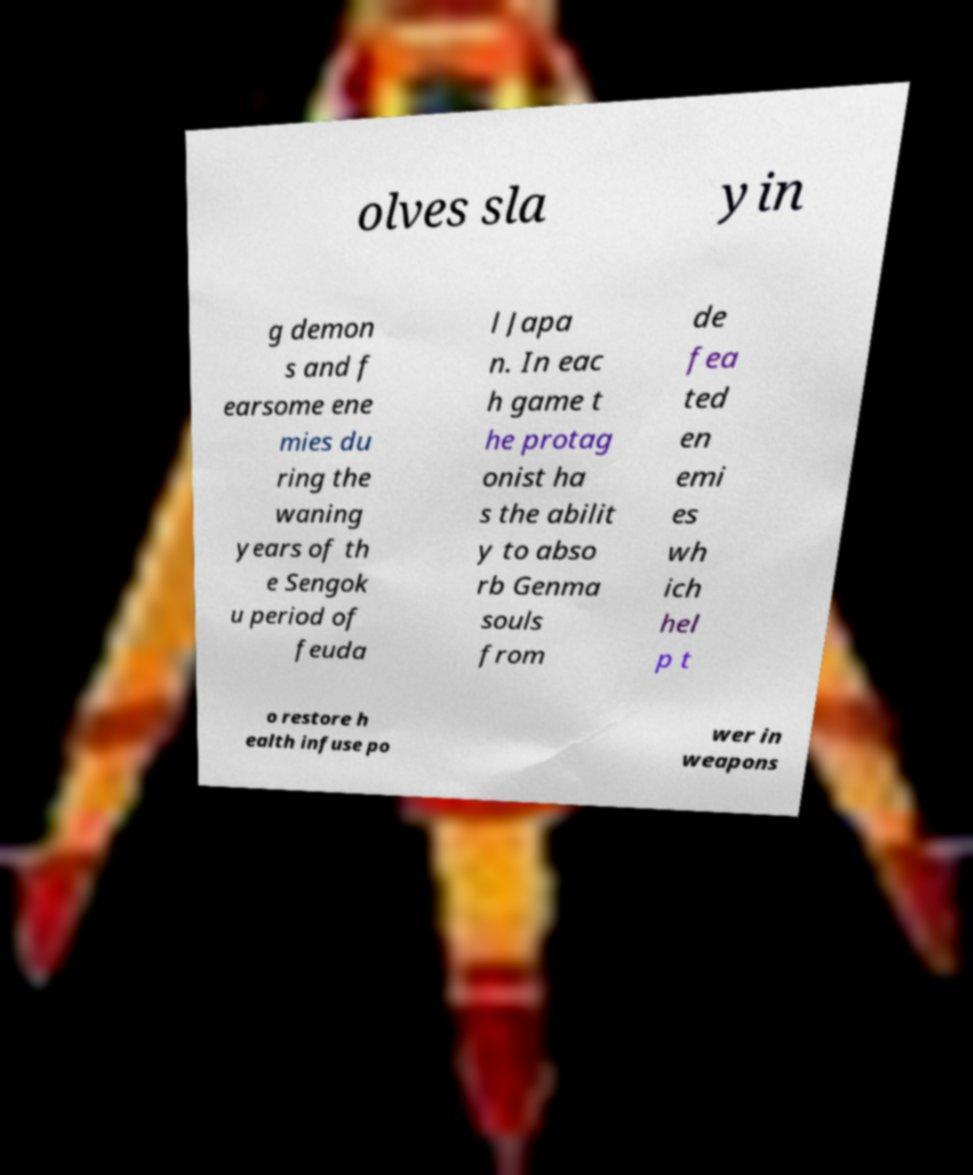Please read and relay the text visible in this image. What does it say? olves sla yin g demon s and f earsome ene mies du ring the waning years of th e Sengok u period of feuda l Japa n. In eac h game t he protag onist ha s the abilit y to abso rb Genma souls from de fea ted en emi es wh ich hel p t o restore h ealth infuse po wer in weapons 